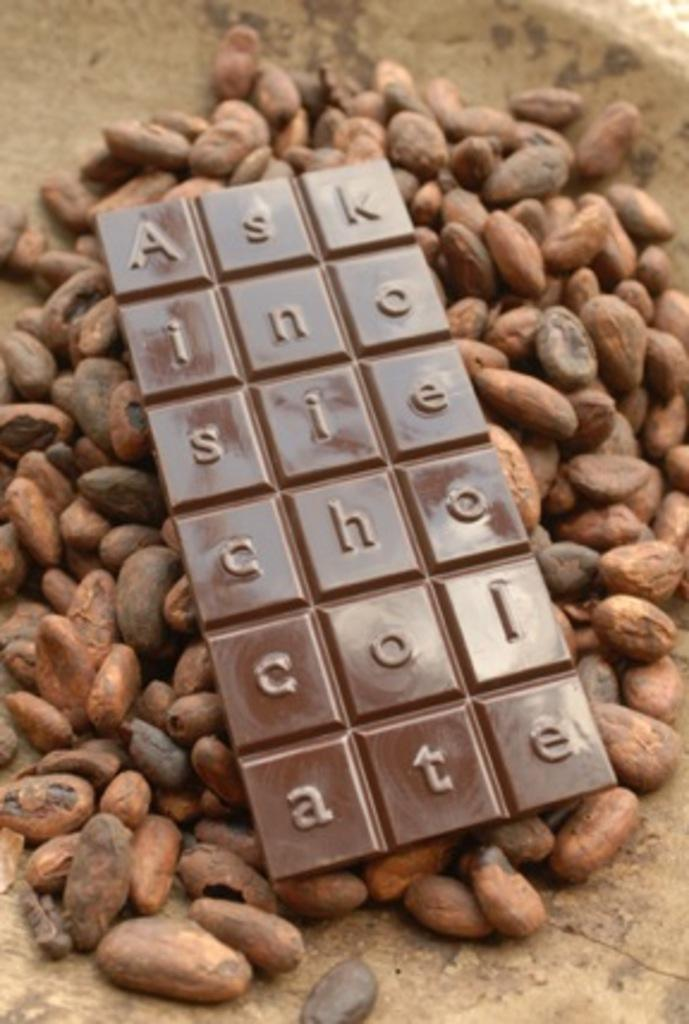What is the main subject of the image? The main subject of the image is a chocolate. What is the chocolate placed on? The chocolate is on nuts. What type of record can be seen playing on the stove in the image? There is no stove or record present in the image; it only features a chocolate on nuts. 